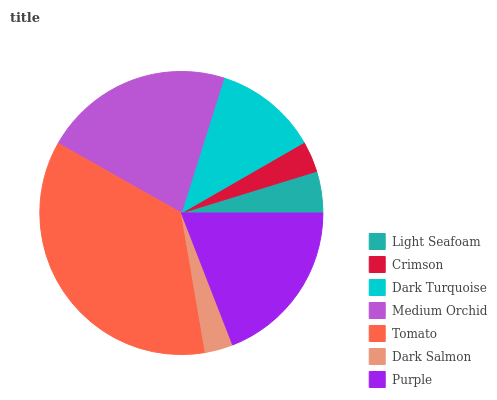Is Dark Salmon the minimum?
Answer yes or no. Yes. Is Tomato the maximum?
Answer yes or no. Yes. Is Crimson the minimum?
Answer yes or no. No. Is Crimson the maximum?
Answer yes or no. No. Is Light Seafoam greater than Crimson?
Answer yes or no. Yes. Is Crimson less than Light Seafoam?
Answer yes or no. Yes. Is Crimson greater than Light Seafoam?
Answer yes or no. No. Is Light Seafoam less than Crimson?
Answer yes or no. No. Is Dark Turquoise the high median?
Answer yes or no. Yes. Is Dark Turquoise the low median?
Answer yes or no. Yes. Is Tomato the high median?
Answer yes or no. No. Is Crimson the low median?
Answer yes or no. No. 